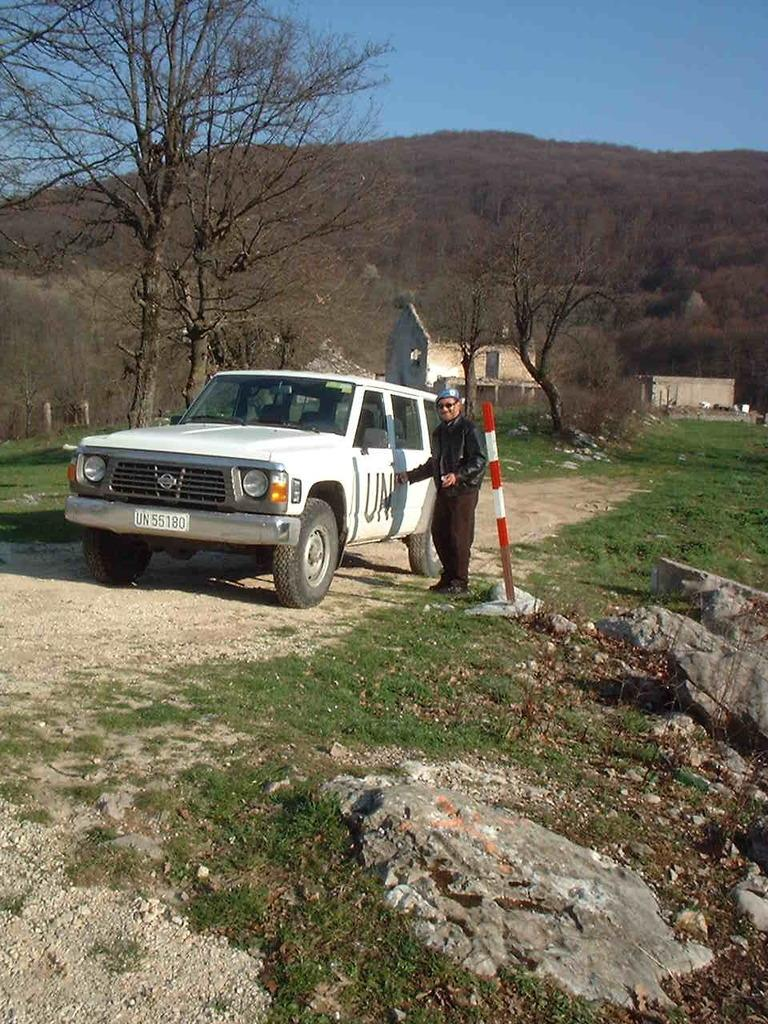What color is the car in the image? The car in the image is white. Who or what is standing beside the car? There is a person standing beside the car. What type of vegetation can be seen in the image? Trees are visible in the image. What is the color of the sky in the image? The sky is blue in the image. What is the person learning from the mother in the image? There is no mother or learning activity present in the image; it only features a person standing beside a white car with trees and a blue sky in the background. 